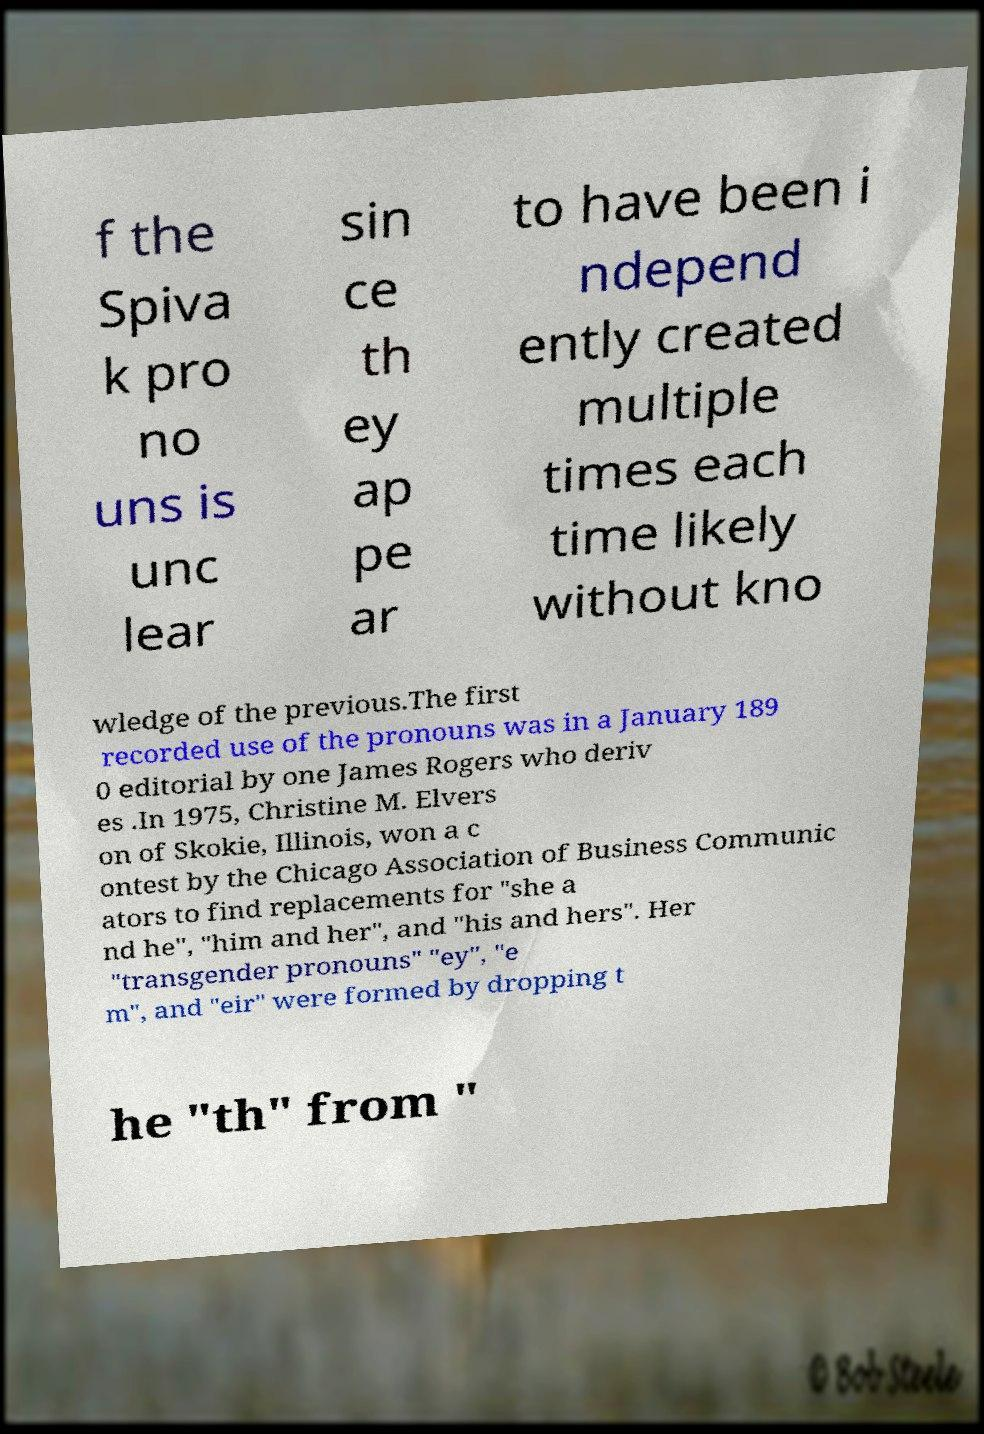There's text embedded in this image that I need extracted. Can you transcribe it verbatim? f the Spiva k pro no uns is unc lear sin ce th ey ap pe ar to have been i ndepend ently created multiple times each time likely without kno wledge of the previous.The first recorded use of the pronouns was in a January 189 0 editorial by one James Rogers who deriv es .In 1975, Christine M. Elvers on of Skokie, Illinois, won a c ontest by the Chicago Association of Business Communic ators to find replacements for "she a nd he", "him and her", and "his and hers". Her "transgender pronouns" "ey", "e m", and "eir" were formed by dropping t he "th" from " 